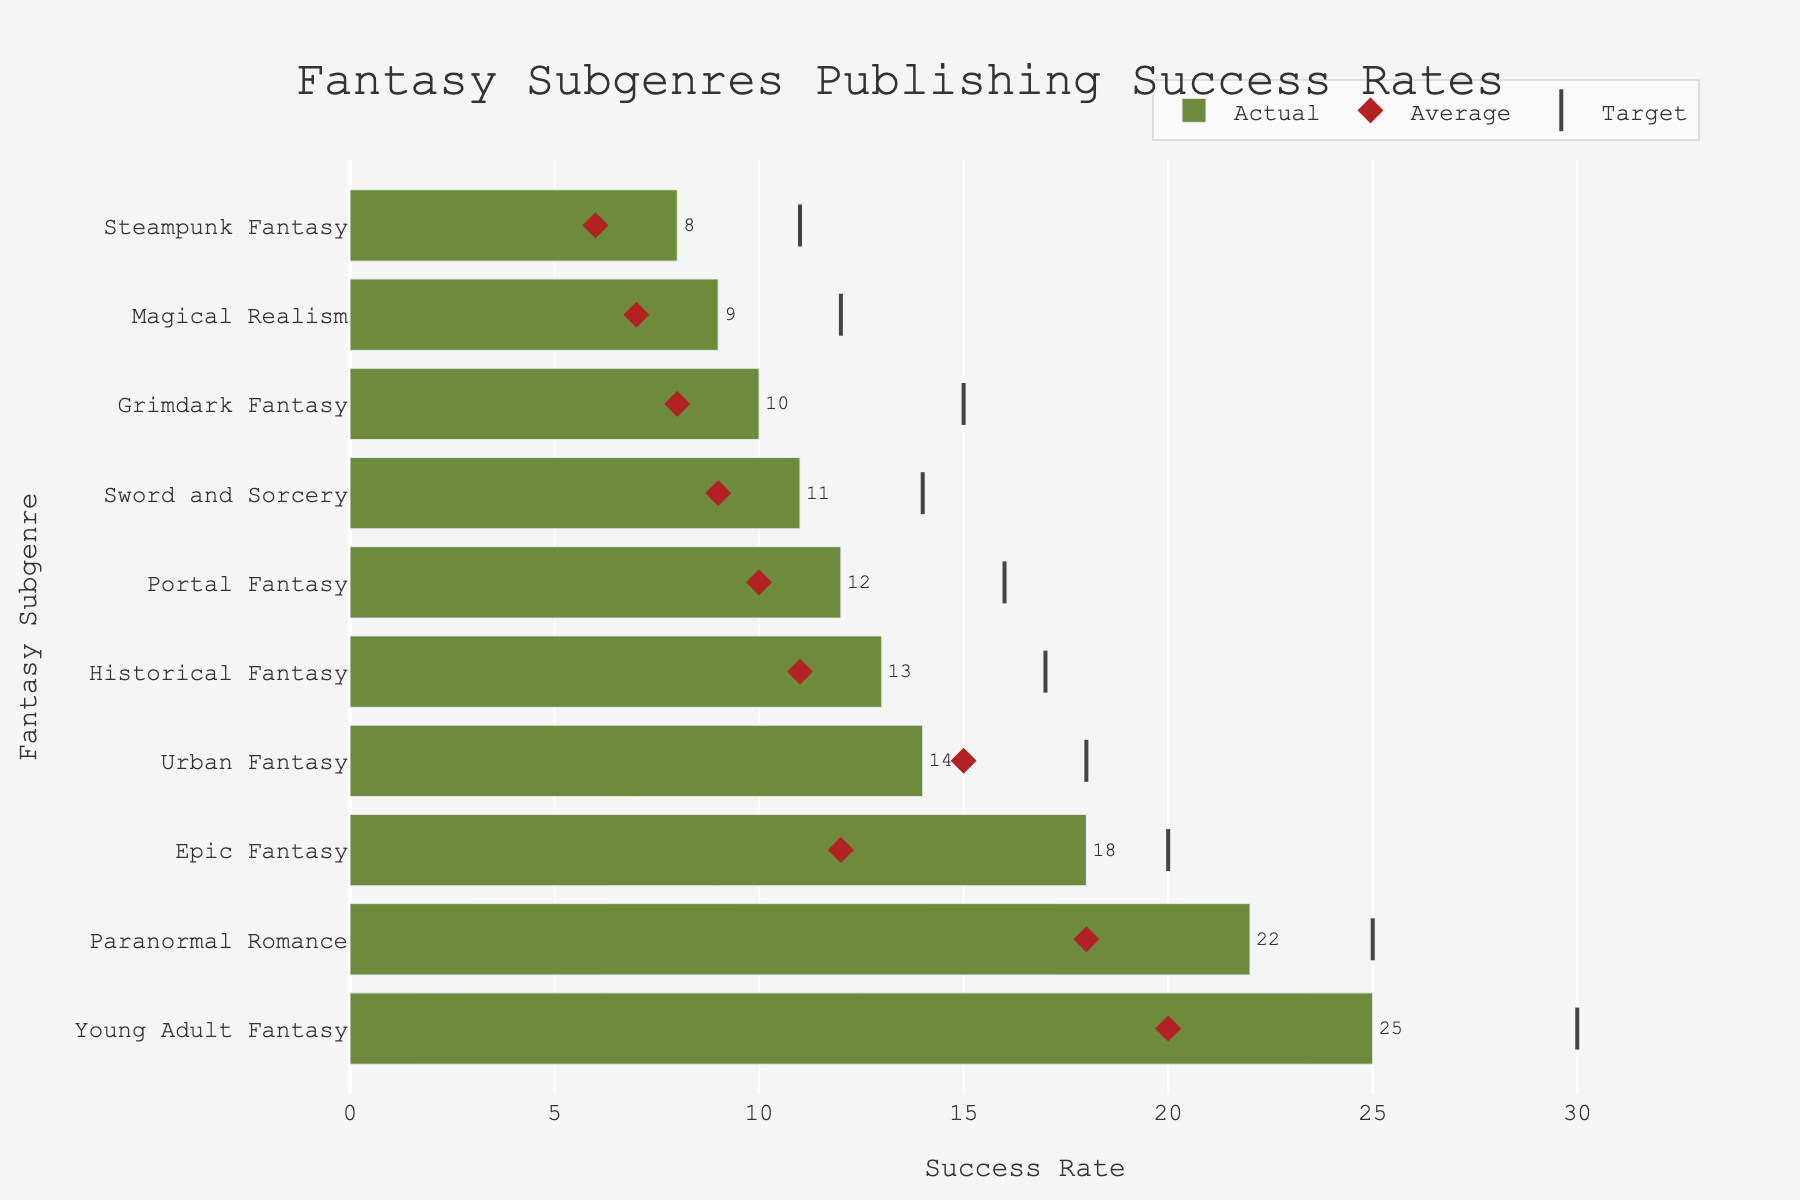Which fantasy subgenre has the highest actual success rate? By examining the bar lengths representing actual success rates, the subgenre with the longest bar is "Young Adult Fantasy" at 25%.
Answer: Young Adult Fantasy Where do the average and actual success rates differ the most? By comparing the distance between the diamond markers (average) and bars (actual) for each subgenre, "Young Adult Fantasy" has the largest difference, with an actual success rate of 25% compared to an average of 20%, totaling a 5% difference.
Answer: Young Adult Fantasy Which subgenres have actual success rates above their target values? By comparing the bars (actual) against the markers (target), "Epic Fantasy" and "Young Adult Fantasy" have bars that extend beyond the target markers.
Answer: Epic Fantasy, Young Adult Fantasy What is the average success rate for Grimdark Fantasy? The diamond marker for "Grimdark Fantasy" shows an average success rate of 8%.
Answer: 8% Which subgenre has the closest actual success rate to its average success rate? By looking at how closely the bars (actual) align with the diamond markers (average), "Urban Fantasy" has actual and average rates that are closest, at 14% actual and 15% average.
Answer: Urban Fantasy What is the difference between the actual success rates of Steampunk Fantasy and Historical Fantasy? The bar for "Steampunk Fantasy" reaches 8%, and for "Historical Fantasy" it reaches 13%. The difference is 13% - 8% = 5%.
Answer: 5% How many subgenres have an actual success rate higher than their average? By counting the bars that are longer than their corresponding diamond markers, 8 subgenres (all except Urban Fantasy and Steampunk Fantasy) have higher actual success rates than their averages.
Answer: 8 Which subgenres have a target value of 25%? The scatter (line-ns marker) for "Paranormal Romance" shows a target value of 25%.
Answer: Paranormal Romance What is the difference between the target and actual success rate for Portal Fantasy? The bar for "Portal Fantasy" shows an actual success rate of 12%, and the target marker is at 16%. The difference is 16% - 12% = 4%.
Answer: 4% What subgenres have actual success rates that meet or exceed industry average across all subgenres? By contrasting each actual bar to the overall average success benchmark of 13%, subgenres "Young Adult Fantasy", "Paranormal Romance", "Epic Fantasy", "Historical Fantasy", and "Portal Fantasy" meet or exceed this average.
Answer: Young Adult Fantasy, Paranormal Romance, Epic Fantasy, Historical Fantasy, Portal Fantasy 